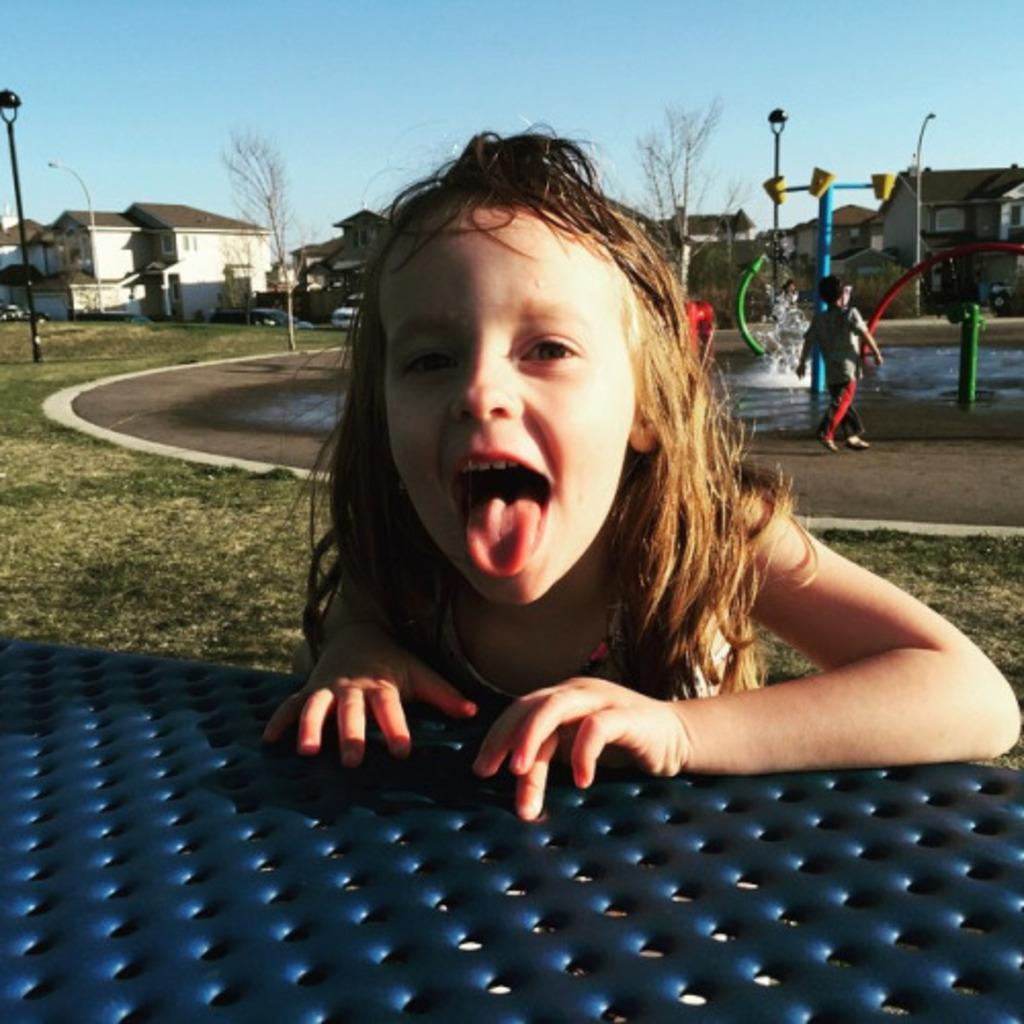Who is present in the image? There is a girl and a boy in the image. What is the girl doing in the image? The girl is smiling in the image. What type of environment is depicted in the image? The image shows grass, water, buildings, trees, and poles. What is the boy doing in the image? The boy is walking on the ground in the image. What can be seen in the background of the image? The sky is visible in the background of the image. What type of act is the girl performing in the image? There is no specific act being performed by the girl in the image; she is simply smiling. Can you hear the boy coughing in the image? The image is silent, so it is not possible to hear the boy coughing. 